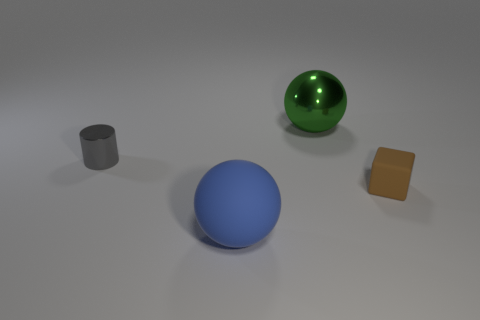There is a tiny object to the right of the big metallic ball; how many big spheres are behind it?
Your answer should be very brief. 1. Is the number of matte things that are behind the green metallic ball less than the number of large spheres?
Provide a short and direct response. Yes. There is a object in front of the brown matte cube in front of the small metallic object; are there any large blue objects that are on the right side of it?
Your answer should be very brief. No. Does the gray object have the same material as the large object to the right of the blue matte ball?
Keep it short and to the point. Yes. There is a ball behind the metallic object to the left of the large rubber sphere; what color is it?
Offer a terse response. Green. Are there any big shiny spheres that have the same color as the tiny block?
Your answer should be compact. No. There is a metallic object on the left side of the rubber object that is on the left side of the metallic object behind the cylinder; how big is it?
Offer a very short reply. Small. Do the tiny gray object and the large object that is behind the brown rubber block have the same shape?
Make the answer very short. No. How many other things are there of the same size as the brown object?
Give a very brief answer. 1. There is a metal thing on the left side of the blue rubber ball; what size is it?
Your response must be concise. Small. 